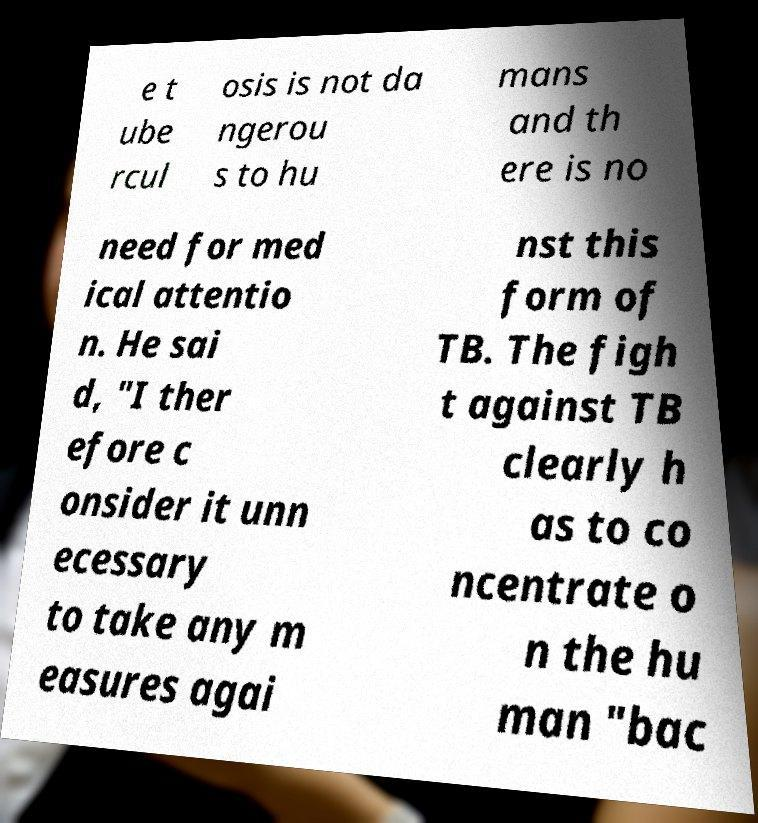For documentation purposes, I need the text within this image transcribed. Could you provide that? e t ube rcul osis is not da ngerou s to hu mans and th ere is no need for med ical attentio n. He sai d, "I ther efore c onsider it unn ecessary to take any m easures agai nst this form of TB. The figh t against TB clearly h as to co ncentrate o n the hu man "bac 